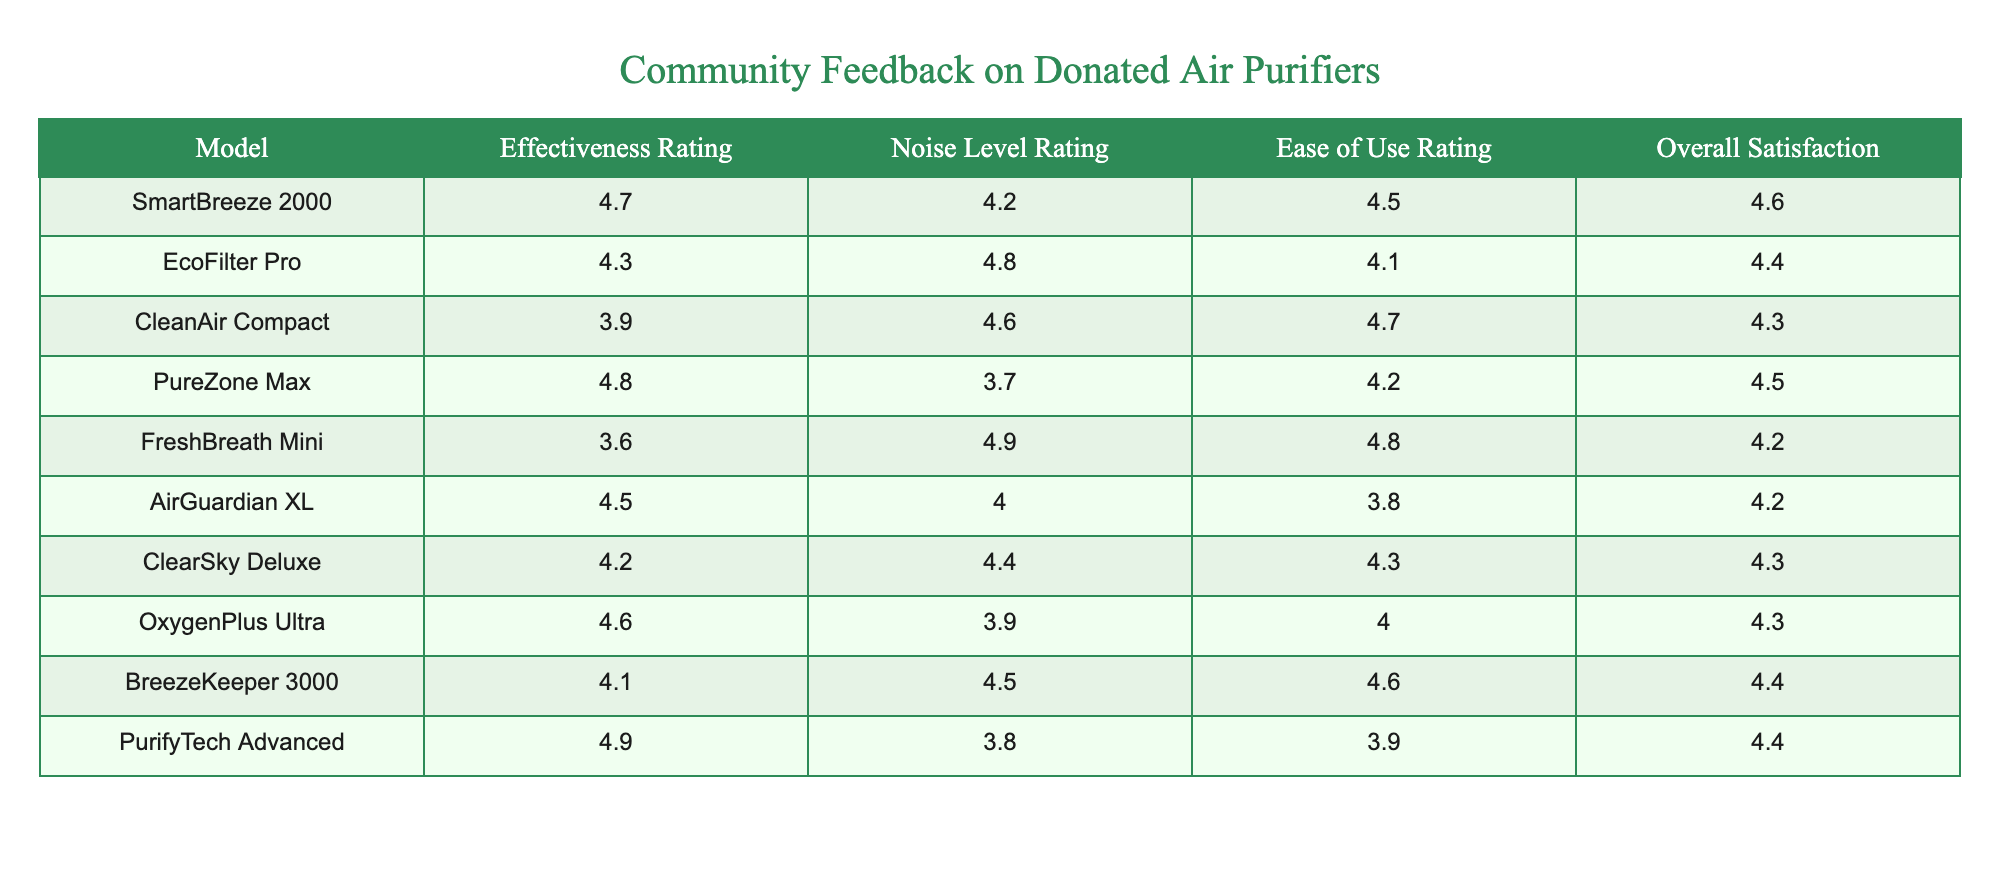What is the highest effectiveness rating among the air purifiers? The effectiveness ratings in the table are: 4.7, 4.3, 3.9, 4.8, 3.6, 4.5, 4.2, 4.6, 4.1, and 4.9. The highest of these is 4.9, which belongs to PurifyTech Advanced.
Answer: 4.9 Which air purifier has the lowest noise level rating? The noise level ratings in the table are: 4.2, 4.8, 4.6, 3.7, 4.9, 4.0, 4.4, 3.9, 4.5, and 3.8. The lowest rating is 3.7, which belongs to PureZone Max.
Answer: PureZone Max What is the average overall satisfaction rating of all the air purifiers? To find the average overall satisfaction, we first sum the ratings: 4.6 + 4.4 + 4.3 + 4.5 + 4.2 + 4.2 + 4.3 + 4.3 + 4.4 + 4.4 = 44.2. There are 10 purifiers, so we divide: 44.2 / 10 = 4.42.
Answer: 4.42 Is the effectiveness rating of CleanAir Compact greater than 4.0? The effectiveness rating for CleanAir Compact is 3.9, which is less than 4.0. Therefore, the statement is false.
Answer: No Which air purifier has the highest ease of use rating, and what is that rating? The ease of use ratings are: 4.5, 4.1, 4.7, 4.2, 4.8, 3.8, 4.3, 4.0, 4.6, and 3.9. The highest is 4.8, which belongs to FreshBreath Mini.
Answer: FreshBreath Mini, 4.8 Is the overall satisfaction rating of PureZone Max higher than that of EcoFilter Pro? The overall satisfaction rating for PureZone Max is 4.5, and for EcoFilter Pro, it is 4.4. Since 4.5 is greater than 4.4, the statement is true.
Answer: Yes Calculate the difference between the highest and lowest effectiveness ratings. The highest effectiveness rating is 4.9 (PurifyTech Advanced), and the lowest is 3.6 (FreshBreath Mini). The difference is 4.9 - 3.6 = 1.3.
Answer: 1.3 Which model has an effectiveness rating lower than 4.0 and a noise level rating higher than 4.5? The models below 4.0 effectiveness ratings are CleanAir Compact (3.9) and FreshBreath Mini (3.6). FreshBreath Mini has a noise level rating of 4.9, which is greater than 4.5. Hence, FreshBreath Mini meets both criteria.
Answer: FreshBreath Mini 